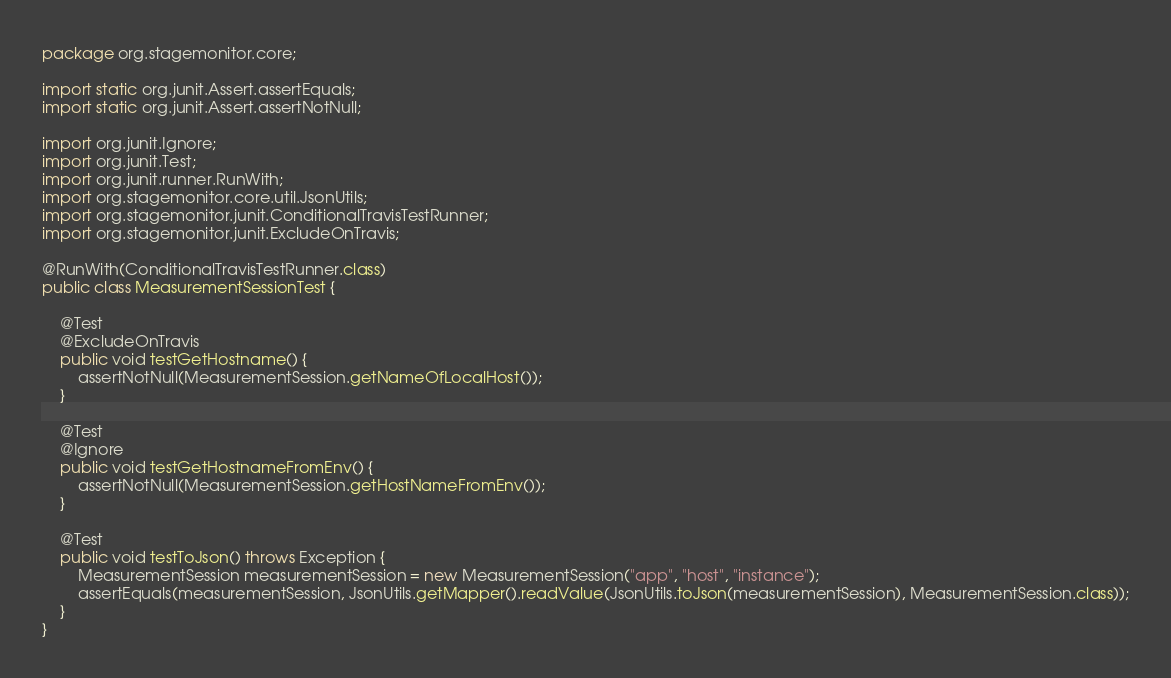<code> <loc_0><loc_0><loc_500><loc_500><_Java_>package org.stagemonitor.core;

import static org.junit.Assert.assertEquals;
import static org.junit.Assert.assertNotNull;

import org.junit.Ignore;
import org.junit.Test;
import org.junit.runner.RunWith;
import org.stagemonitor.core.util.JsonUtils;
import org.stagemonitor.junit.ConditionalTravisTestRunner;
import org.stagemonitor.junit.ExcludeOnTravis;

@RunWith(ConditionalTravisTestRunner.class)
public class MeasurementSessionTest {

	@Test
	@ExcludeOnTravis
	public void testGetHostname() {
		assertNotNull(MeasurementSession.getNameOfLocalHost());
	}

	@Test
	@Ignore
	public void testGetHostnameFromEnv() {
		assertNotNull(MeasurementSession.getHostNameFromEnv());
	}

	@Test
	public void testToJson() throws Exception {
		MeasurementSession measurementSession = new MeasurementSession("app", "host", "instance");
		assertEquals(measurementSession, JsonUtils.getMapper().readValue(JsonUtils.toJson(measurementSession), MeasurementSession.class));
	}
}
</code> 